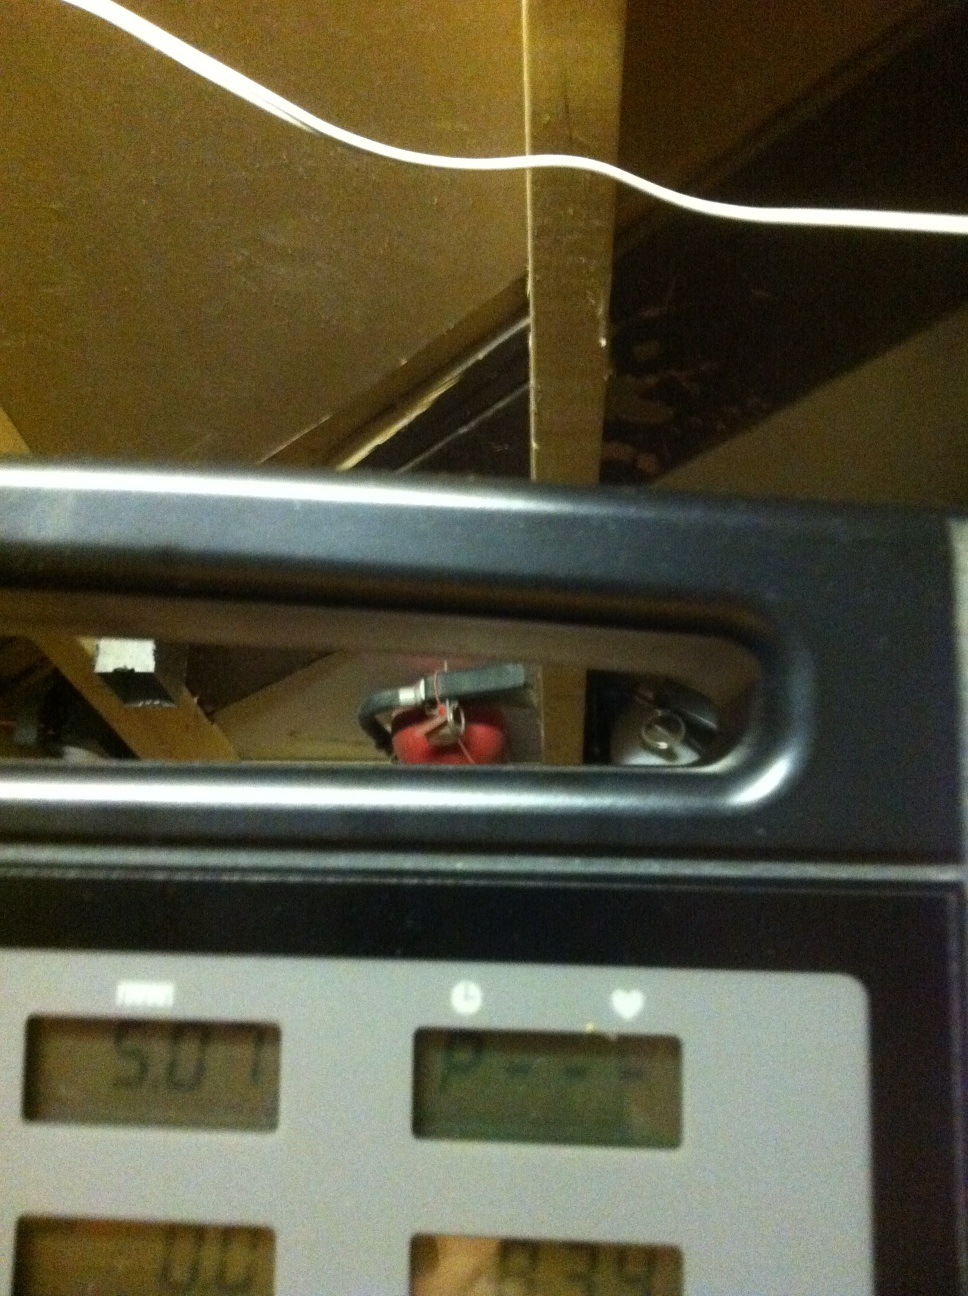Can you tell me what the current speed and heart rate readings are? The display shows a distance of 5.07 miles, but it seems the speed and heart rate readings are not visible or not currently displayed on this segment of the screen. Please check the respective sections for speed and heart rate on the treadmill control panel. 